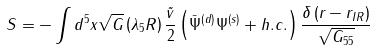Convert formula to latex. <formula><loc_0><loc_0><loc_500><loc_500>S = - \int d ^ { 5 } x \sqrt { G } \left ( \lambda _ { 5 } R \right ) \frac { \tilde { v } } { 2 } \left ( \bar { \Psi } ^ { \left ( d \right ) } \Psi ^ { \left ( s \right ) } + h . c . \right ) \frac { \delta \left ( r - r _ { I R } \right ) } { \sqrt { G _ { 5 5 } } }</formula> 